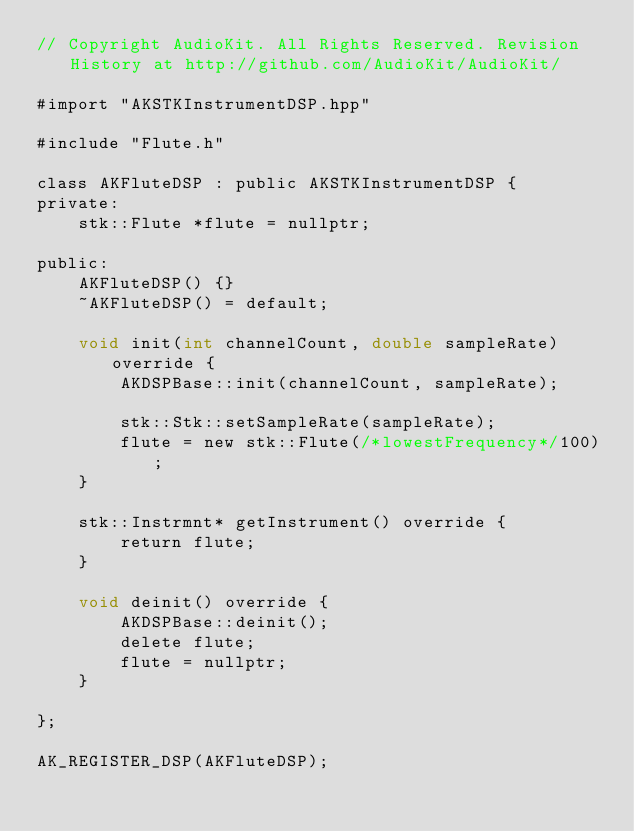Convert code to text. <code><loc_0><loc_0><loc_500><loc_500><_ObjectiveC_>// Copyright AudioKit. All Rights Reserved. Revision History at http://github.com/AudioKit/AudioKit/

#import "AKSTKInstrumentDSP.hpp"

#include "Flute.h"

class AKFluteDSP : public AKSTKInstrumentDSP {
private:
    stk::Flute *flute = nullptr;

public:
    AKFluteDSP() {}
    ~AKFluteDSP() = default;

    void init(int channelCount, double sampleRate) override {
        AKDSPBase::init(channelCount, sampleRate);

        stk::Stk::setSampleRate(sampleRate);
        flute = new stk::Flute(/*lowestFrequency*/100);
    }

    stk::Instrmnt* getInstrument() override {
        return flute;
    }

    void deinit() override {
        AKDSPBase::deinit();
        delete flute;
        flute = nullptr;
    }

};

AK_REGISTER_DSP(AKFluteDSP);
</code> 